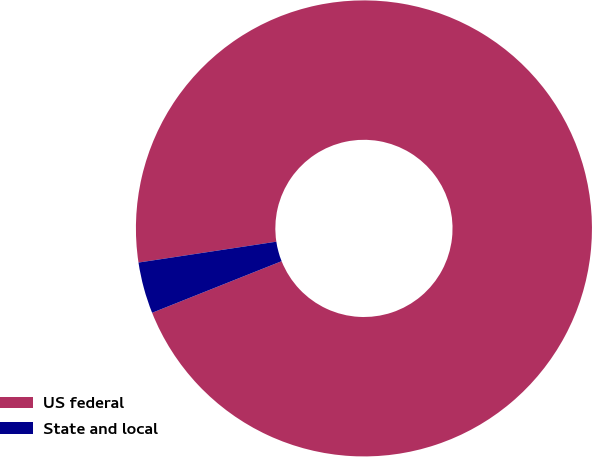Convert chart. <chart><loc_0><loc_0><loc_500><loc_500><pie_chart><fcel>US federal<fcel>State and local<nl><fcel>96.36%<fcel>3.64%<nl></chart> 